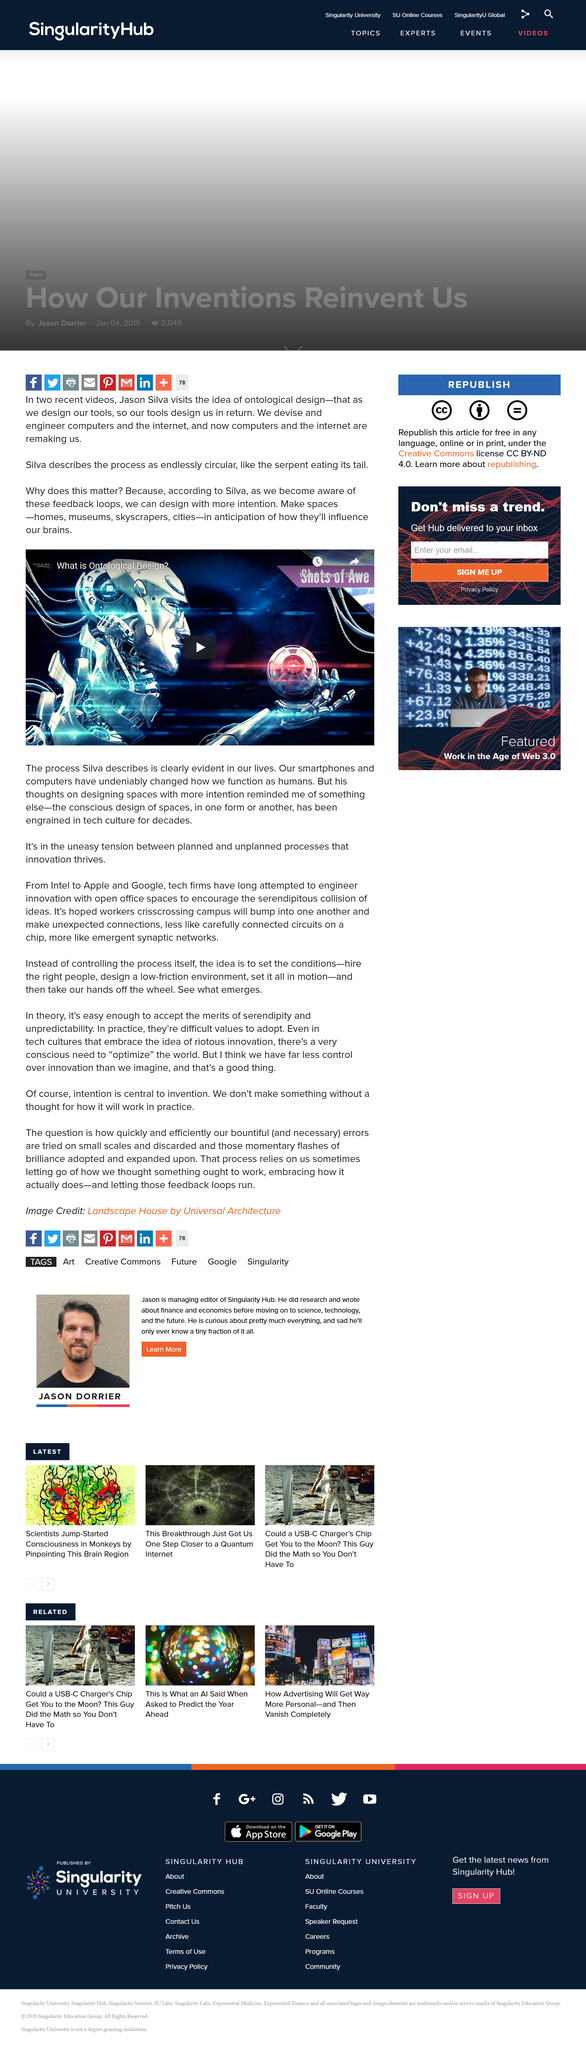Outline some significant characteristics in this image. What topic is Silva describing? Ontological design. Silva believes that spaces should be designed with more intention. Smartphones and computers have fundamentally altered the way humans function, transforming the way we communicate, work, and interact with one another. 